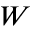<formula> <loc_0><loc_0><loc_500><loc_500>W</formula> 